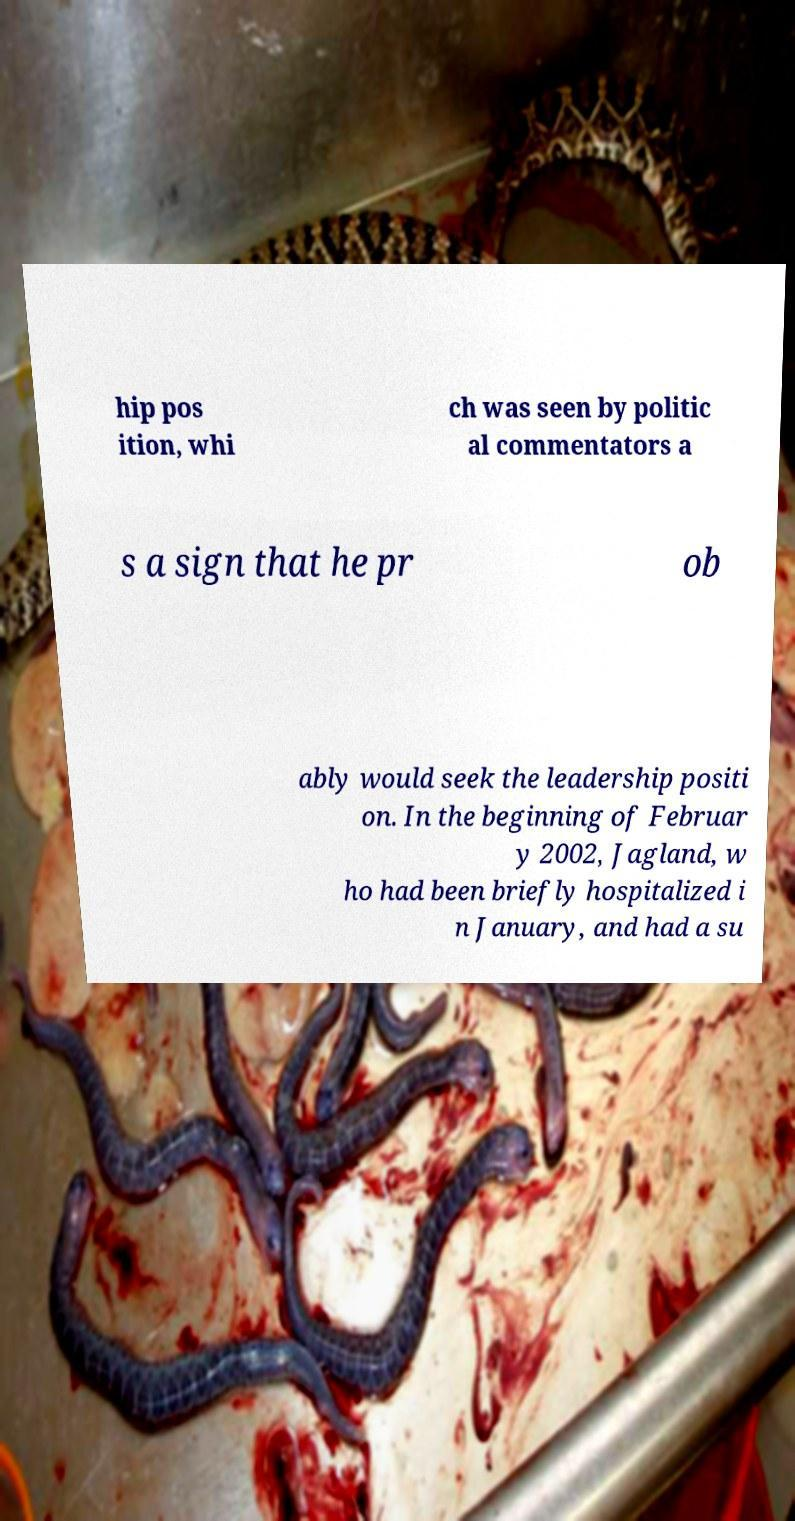Could you assist in decoding the text presented in this image and type it out clearly? hip pos ition, whi ch was seen by politic al commentators a s a sign that he pr ob ably would seek the leadership positi on. In the beginning of Februar y 2002, Jagland, w ho had been briefly hospitalized i n January, and had a su 